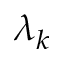<formula> <loc_0><loc_0><loc_500><loc_500>\lambda _ { k }</formula> 